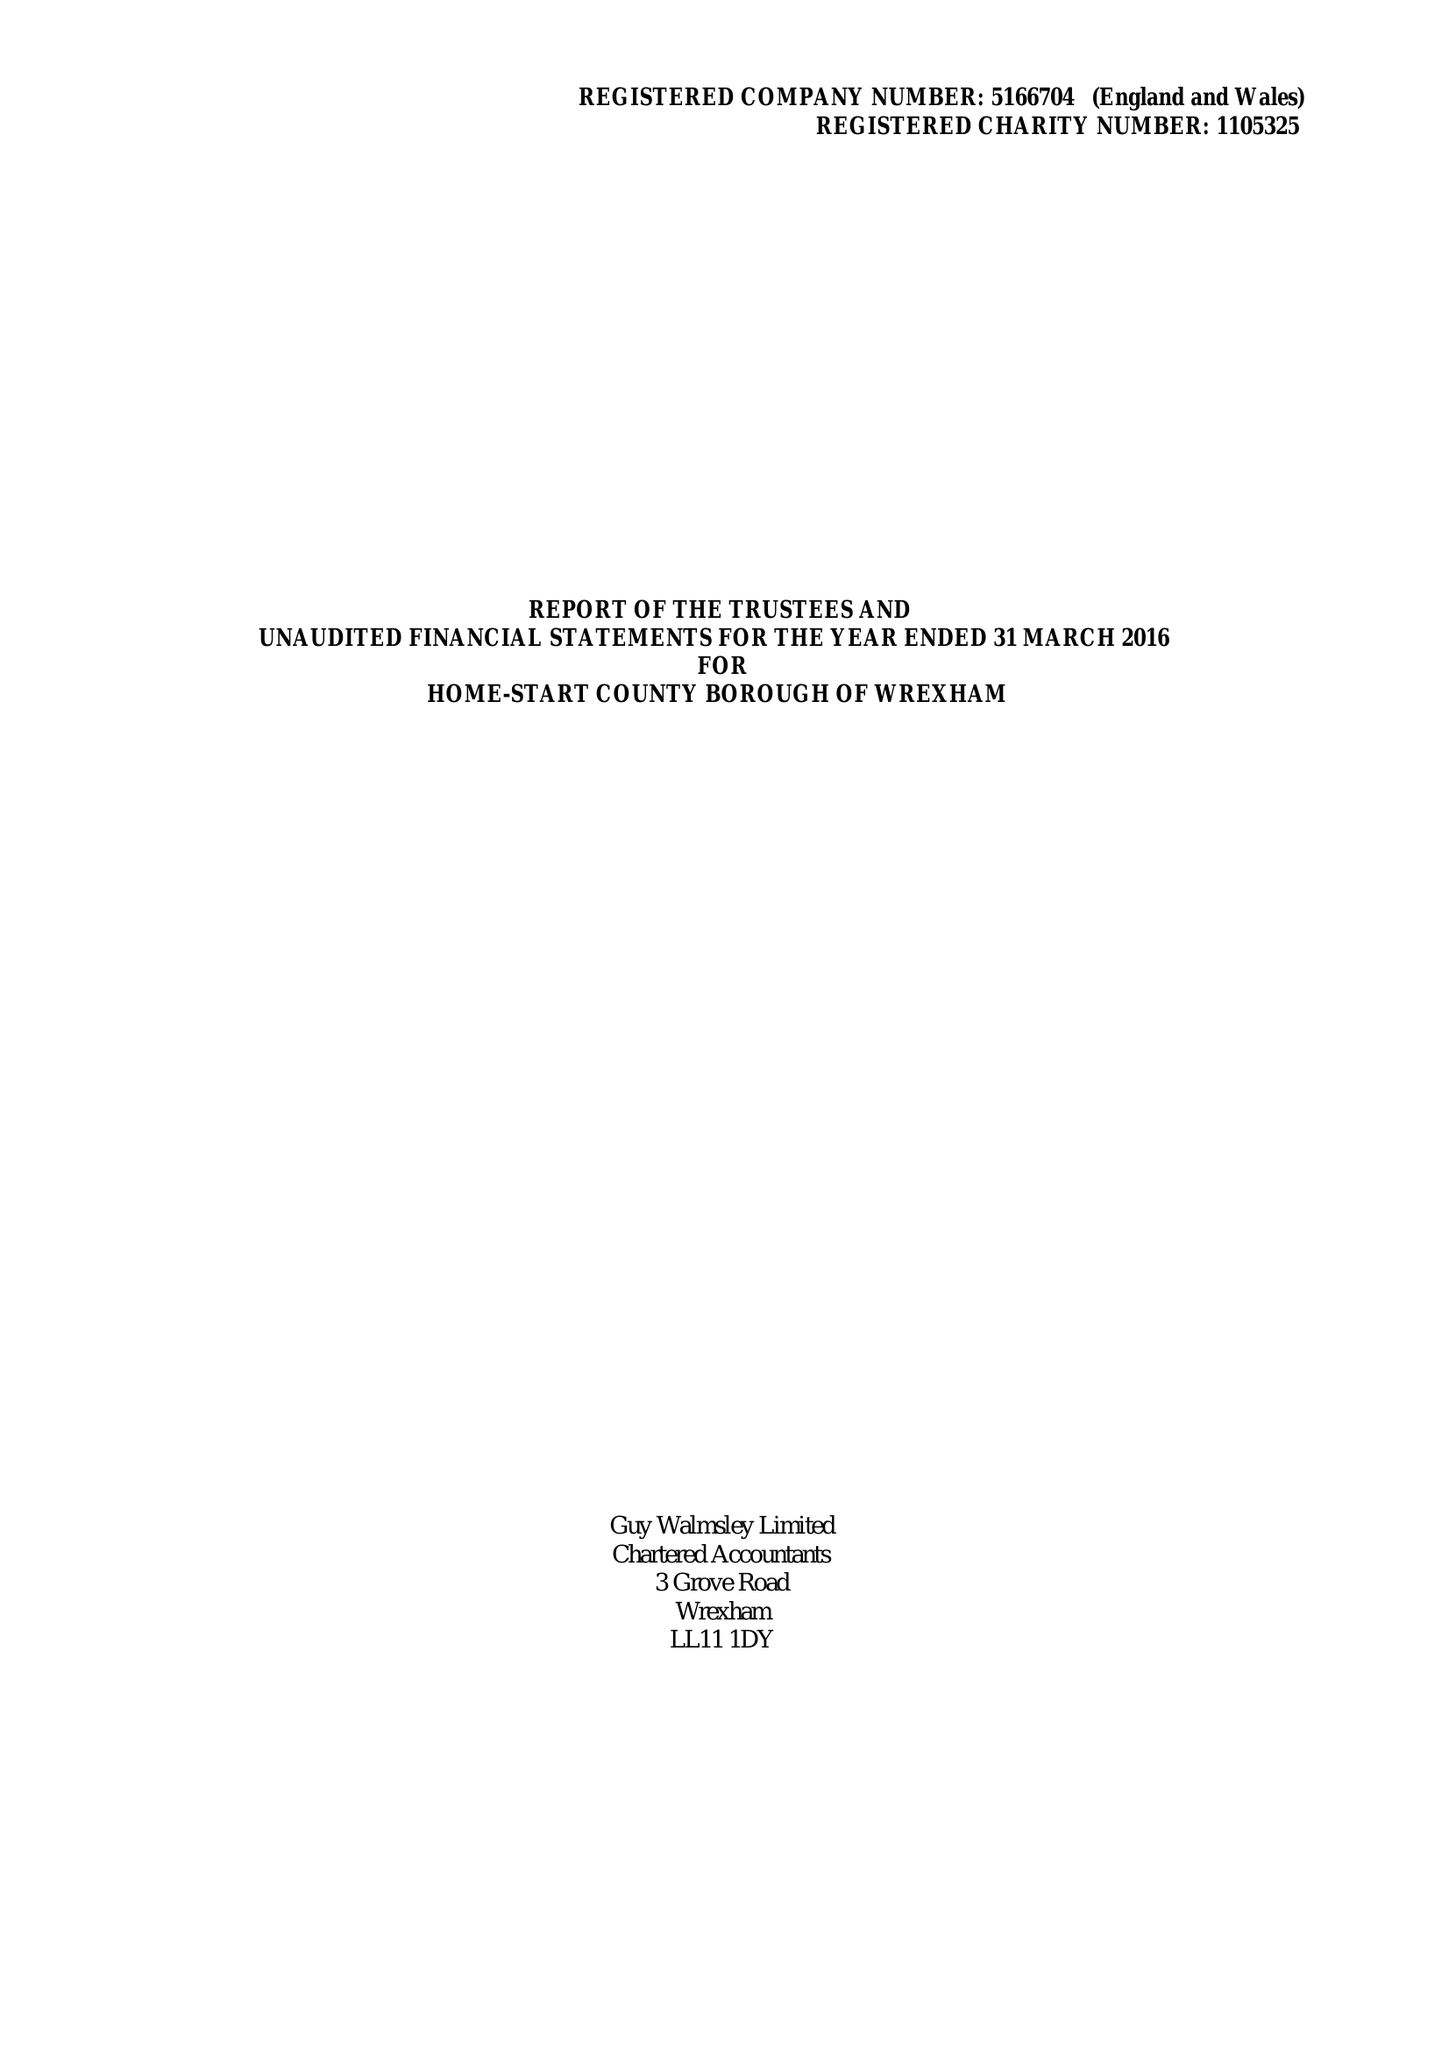What is the value for the report_date?
Answer the question using a single word or phrase. 2016-03-31 